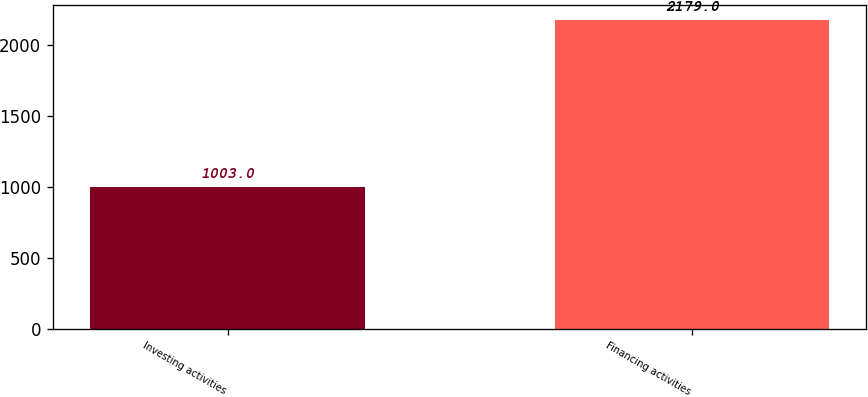Convert chart. <chart><loc_0><loc_0><loc_500><loc_500><bar_chart><fcel>Investing activities<fcel>Financing activities<nl><fcel>1003<fcel>2179<nl></chart> 